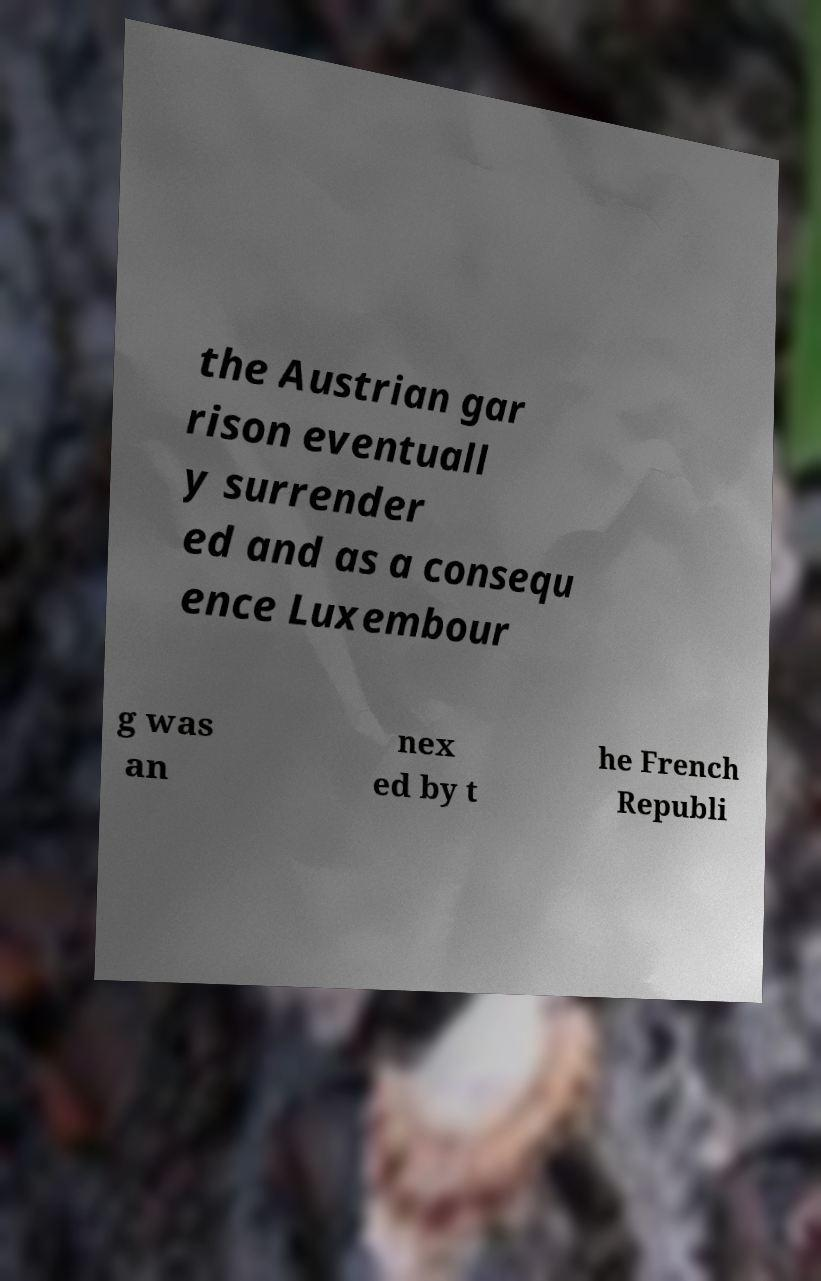Could you assist in decoding the text presented in this image and type it out clearly? the Austrian gar rison eventuall y surrender ed and as a consequ ence Luxembour g was an nex ed by t he French Republi 